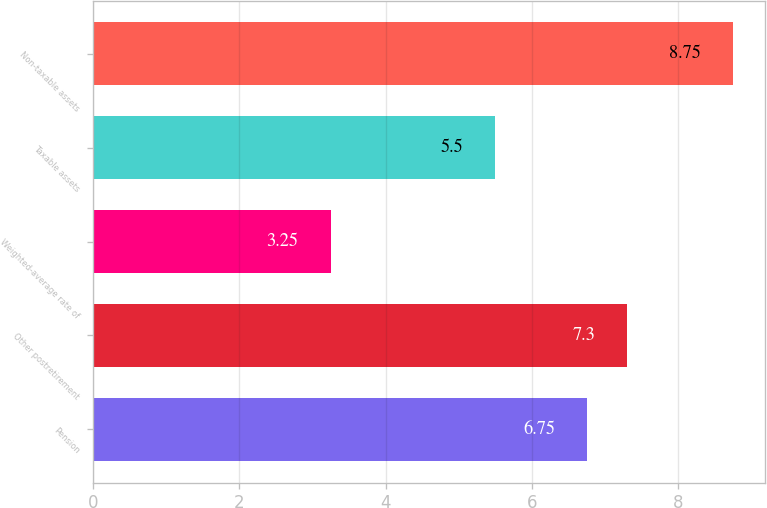<chart> <loc_0><loc_0><loc_500><loc_500><bar_chart><fcel>Pension<fcel>Other postretirement<fcel>Weighted-average rate of<fcel>Taxable assets<fcel>Non-taxable assets<nl><fcel>6.75<fcel>7.3<fcel>3.25<fcel>5.5<fcel>8.75<nl></chart> 